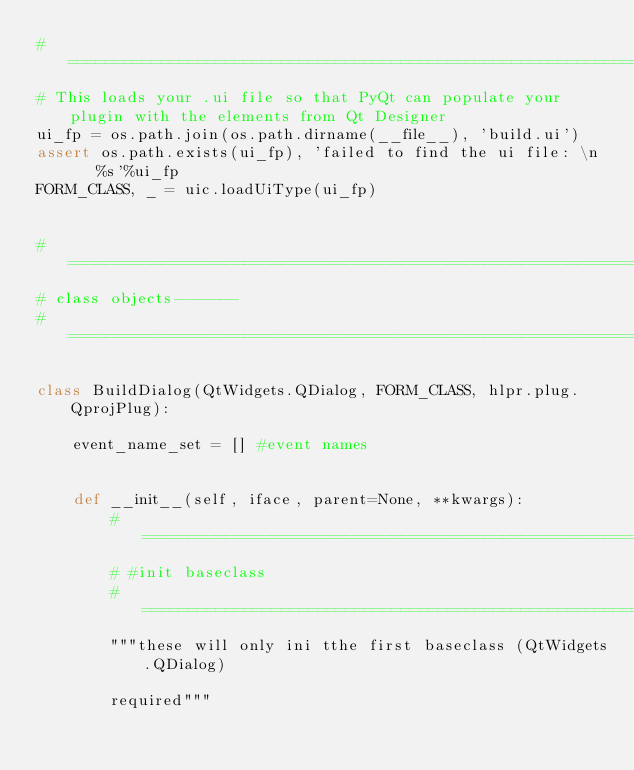Convert code to text. <code><loc_0><loc_0><loc_500><loc_500><_Python_>#===============================================================================
# This loads your .ui file so that PyQt can populate your plugin with the elements from Qt Designer
ui_fp = os.path.join(os.path.dirname(__file__), 'build.ui')
assert os.path.exists(ui_fp), 'failed to find the ui file: \n    %s'%ui_fp
FORM_CLASS, _ = uic.loadUiType(ui_fp)


#===============================================================================
# class objects-------
#===============================================================================

class BuildDialog(QtWidgets.QDialog, FORM_CLASS, hlpr.plug.QprojPlug):
    
    event_name_set = [] #event names
    

    def __init__(self, iface, parent=None, **kwargs):
        #=======================================================================
        # #init baseclass
        #=======================================================================
        """these will only ini tthe first baseclass (QtWidgets.QDialog)
        
        required"""
        </code> 